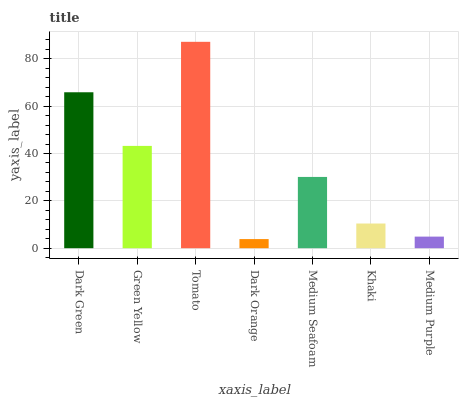Is Green Yellow the minimum?
Answer yes or no. No. Is Green Yellow the maximum?
Answer yes or no. No. Is Dark Green greater than Green Yellow?
Answer yes or no. Yes. Is Green Yellow less than Dark Green?
Answer yes or no. Yes. Is Green Yellow greater than Dark Green?
Answer yes or no. No. Is Dark Green less than Green Yellow?
Answer yes or no. No. Is Medium Seafoam the high median?
Answer yes or no. Yes. Is Medium Seafoam the low median?
Answer yes or no. Yes. Is Green Yellow the high median?
Answer yes or no. No. Is Green Yellow the low median?
Answer yes or no. No. 